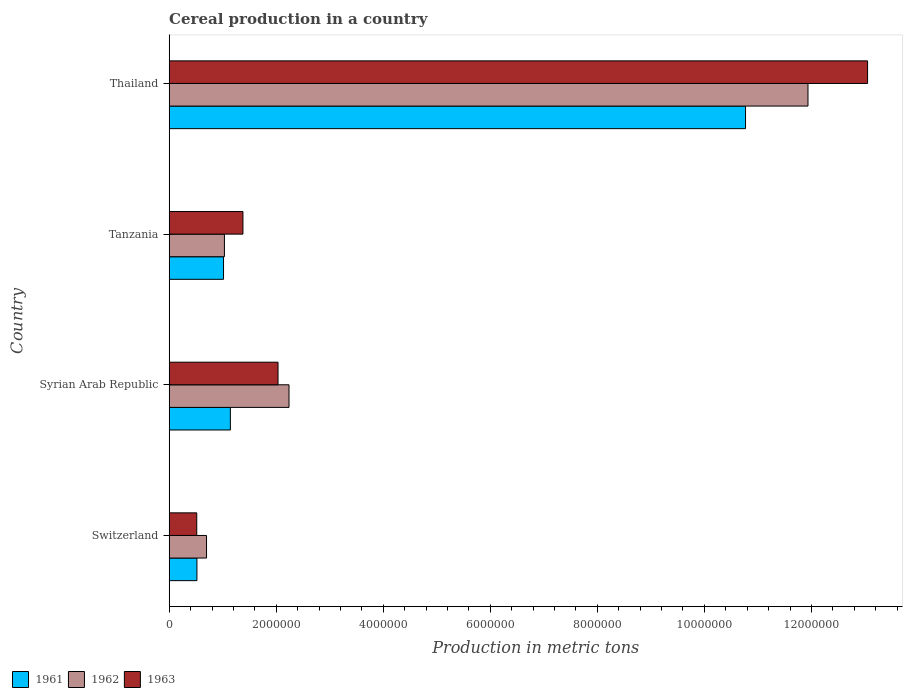How many different coloured bars are there?
Provide a succinct answer. 3. How many groups of bars are there?
Your response must be concise. 4. Are the number of bars per tick equal to the number of legend labels?
Offer a terse response. Yes. Are the number of bars on each tick of the Y-axis equal?
Offer a terse response. Yes. How many bars are there on the 2nd tick from the bottom?
Your answer should be very brief. 3. What is the label of the 4th group of bars from the top?
Your response must be concise. Switzerland. What is the total cereal production in 1961 in Syrian Arab Republic?
Your response must be concise. 1.14e+06. Across all countries, what is the maximum total cereal production in 1962?
Offer a very short reply. 1.19e+07. Across all countries, what is the minimum total cereal production in 1961?
Give a very brief answer. 5.18e+05. In which country was the total cereal production in 1962 maximum?
Your answer should be very brief. Thailand. In which country was the total cereal production in 1962 minimum?
Your answer should be compact. Switzerland. What is the total total cereal production in 1963 in the graph?
Offer a terse response. 1.70e+07. What is the difference between the total cereal production in 1962 in Switzerland and that in Thailand?
Offer a terse response. -1.12e+07. What is the difference between the total cereal production in 1961 in Switzerland and the total cereal production in 1963 in Tanzania?
Make the answer very short. -8.60e+05. What is the average total cereal production in 1962 per country?
Your answer should be compact. 3.98e+06. What is the difference between the total cereal production in 1961 and total cereal production in 1963 in Tanzania?
Your answer should be compact. -3.63e+05. What is the ratio of the total cereal production in 1961 in Syrian Arab Republic to that in Tanzania?
Provide a succinct answer. 1.13. Is the total cereal production in 1962 in Tanzania less than that in Thailand?
Keep it short and to the point. Yes. What is the difference between the highest and the second highest total cereal production in 1963?
Offer a terse response. 1.10e+07. What is the difference between the highest and the lowest total cereal production in 1962?
Provide a short and direct response. 1.12e+07. What does the 1st bar from the bottom in Tanzania represents?
Your answer should be very brief. 1961. How many bars are there?
Your answer should be very brief. 12. Are all the bars in the graph horizontal?
Keep it short and to the point. Yes. How many countries are there in the graph?
Your answer should be compact. 4. Does the graph contain grids?
Give a very brief answer. No. Where does the legend appear in the graph?
Provide a succinct answer. Bottom left. How many legend labels are there?
Keep it short and to the point. 3. How are the legend labels stacked?
Offer a very short reply. Horizontal. What is the title of the graph?
Offer a very short reply. Cereal production in a country. What is the label or title of the X-axis?
Offer a terse response. Production in metric tons. What is the label or title of the Y-axis?
Provide a succinct answer. Country. What is the Production in metric tons in 1961 in Switzerland?
Your answer should be compact. 5.18e+05. What is the Production in metric tons of 1962 in Switzerland?
Offer a terse response. 6.97e+05. What is the Production in metric tons of 1963 in Switzerland?
Give a very brief answer. 5.15e+05. What is the Production in metric tons in 1961 in Syrian Arab Republic?
Your answer should be very brief. 1.14e+06. What is the Production in metric tons of 1962 in Syrian Arab Republic?
Make the answer very short. 2.24e+06. What is the Production in metric tons of 1963 in Syrian Arab Republic?
Offer a very short reply. 2.03e+06. What is the Production in metric tons of 1961 in Tanzania?
Your answer should be compact. 1.02e+06. What is the Production in metric tons of 1962 in Tanzania?
Make the answer very short. 1.03e+06. What is the Production in metric tons of 1963 in Tanzania?
Your response must be concise. 1.38e+06. What is the Production in metric tons of 1961 in Thailand?
Offer a terse response. 1.08e+07. What is the Production in metric tons in 1962 in Thailand?
Your answer should be compact. 1.19e+07. What is the Production in metric tons of 1963 in Thailand?
Your answer should be compact. 1.30e+07. Across all countries, what is the maximum Production in metric tons of 1961?
Your response must be concise. 1.08e+07. Across all countries, what is the maximum Production in metric tons in 1962?
Ensure brevity in your answer.  1.19e+07. Across all countries, what is the maximum Production in metric tons in 1963?
Make the answer very short. 1.30e+07. Across all countries, what is the minimum Production in metric tons of 1961?
Make the answer very short. 5.18e+05. Across all countries, what is the minimum Production in metric tons in 1962?
Keep it short and to the point. 6.97e+05. Across all countries, what is the minimum Production in metric tons of 1963?
Provide a short and direct response. 5.15e+05. What is the total Production in metric tons of 1961 in the graph?
Provide a succinct answer. 1.34e+07. What is the total Production in metric tons in 1962 in the graph?
Ensure brevity in your answer.  1.59e+07. What is the total Production in metric tons in 1963 in the graph?
Ensure brevity in your answer.  1.70e+07. What is the difference between the Production in metric tons in 1961 in Switzerland and that in Syrian Arab Republic?
Your answer should be compact. -6.25e+05. What is the difference between the Production in metric tons of 1962 in Switzerland and that in Syrian Arab Republic?
Provide a succinct answer. -1.54e+06. What is the difference between the Production in metric tons in 1963 in Switzerland and that in Syrian Arab Republic?
Ensure brevity in your answer.  -1.52e+06. What is the difference between the Production in metric tons in 1961 in Switzerland and that in Tanzania?
Make the answer very short. -4.97e+05. What is the difference between the Production in metric tons of 1962 in Switzerland and that in Tanzania?
Make the answer very short. -3.34e+05. What is the difference between the Production in metric tons in 1963 in Switzerland and that in Tanzania?
Provide a succinct answer. -8.63e+05. What is the difference between the Production in metric tons of 1961 in Switzerland and that in Thailand?
Provide a short and direct response. -1.03e+07. What is the difference between the Production in metric tons of 1962 in Switzerland and that in Thailand?
Provide a short and direct response. -1.12e+07. What is the difference between the Production in metric tons of 1963 in Switzerland and that in Thailand?
Make the answer very short. -1.25e+07. What is the difference between the Production in metric tons in 1961 in Syrian Arab Republic and that in Tanzania?
Your response must be concise. 1.28e+05. What is the difference between the Production in metric tons of 1962 in Syrian Arab Republic and that in Tanzania?
Give a very brief answer. 1.21e+06. What is the difference between the Production in metric tons in 1963 in Syrian Arab Republic and that in Tanzania?
Provide a succinct answer. 6.56e+05. What is the difference between the Production in metric tons of 1961 in Syrian Arab Republic and that in Thailand?
Ensure brevity in your answer.  -9.63e+06. What is the difference between the Production in metric tons of 1962 in Syrian Arab Republic and that in Thailand?
Your response must be concise. -9.70e+06. What is the difference between the Production in metric tons of 1963 in Syrian Arab Republic and that in Thailand?
Offer a very short reply. -1.10e+07. What is the difference between the Production in metric tons of 1961 in Tanzania and that in Thailand?
Make the answer very short. -9.75e+06. What is the difference between the Production in metric tons in 1962 in Tanzania and that in Thailand?
Provide a succinct answer. -1.09e+07. What is the difference between the Production in metric tons of 1963 in Tanzania and that in Thailand?
Provide a short and direct response. -1.17e+07. What is the difference between the Production in metric tons in 1961 in Switzerland and the Production in metric tons in 1962 in Syrian Arab Republic?
Keep it short and to the point. -1.72e+06. What is the difference between the Production in metric tons in 1961 in Switzerland and the Production in metric tons in 1963 in Syrian Arab Republic?
Make the answer very short. -1.52e+06. What is the difference between the Production in metric tons in 1962 in Switzerland and the Production in metric tons in 1963 in Syrian Arab Republic?
Your answer should be very brief. -1.34e+06. What is the difference between the Production in metric tons in 1961 in Switzerland and the Production in metric tons in 1962 in Tanzania?
Keep it short and to the point. -5.14e+05. What is the difference between the Production in metric tons of 1961 in Switzerland and the Production in metric tons of 1963 in Tanzania?
Offer a very short reply. -8.60e+05. What is the difference between the Production in metric tons of 1962 in Switzerland and the Production in metric tons of 1963 in Tanzania?
Offer a very short reply. -6.80e+05. What is the difference between the Production in metric tons in 1961 in Switzerland and the Production in metric tons in 1962 in Thailand?
Make the answer very short. -1.14e+07. What is the difference between the Production in metric tons in 1961 in Switzerland and the Production in metric tons in 1963 in Thailand?
Keep it short and to the point. -1.25e+07. What is the difference between the Production in metric tons of 1962 in Switzerland and the Production in metric tons of 1963 in Thailand?
Your answer should be very brief. -1.24e+07. What is the difference between the Production in metric tons in 1961 in Syrian Arab Republic and the Production in metric tons in 1962 in Tanzania?
Ensure brevity in your answer.  1.11e+05. What is the difference between the Production in metric tons of 1961 in Syrian Arab Republic and the Production in metric tons of 1963 in Tanzania?
Provide a succinct answer. -2.35e+05. What is the difference between the Production in metric tons of 1962 in Syrian Arab Republic and the Production in metric tons of 1963 in Tanzania?
Make the answer very short. 8.61e+05. What is the difference between the Production in metric tons in 1961 in Syrian Arab Republic and the Production in metric tons in 1962 in Thailand?
Your answer should be very brief. -1.08e+07. What is the difference between the Production in metric tons of 1961 in Syrian Arab Republic and the Production in metric tons of 1963 in Thailand?
Provide a succinct answer. -1.19e+07. What is the difference between the Production in metric tons in 1962 in Syrian Arab Republic and the Production in metric tons in 1963 in Thailand?
Offer a terse response. -1.08e+07. What is the difference between the Production in metric tons of 1961 in Tanzania and the Production in metric tons of 1962 in Thailand?
Provide a short and direct response. -1.09e+07. What is the difference between the Production in metric tons in 1961 in Tanzania and the Production in metric tons in 1963 in Thailand?
Provide a succinct answer. -1.20e+07. What is the difference between the Production in metric tons in 1962 in Tanzania and the Production in metric tons in 1963 in Thailand?
Your response must be concise. -1.20e+07. What is the average Production in metric tons of 1961 per country?
Give a very brief answer. 3.36e+06. What is the average Production in metric tons of 1962 per country?
Your response must be concise. 3.98e+06. What is the average Production in metric tons in 1963 per country?
Ensure brevity in your answer.  4.24e+06. What is the difference between the Production in metric tons of 1961 and Production in metric tons of 1962 in Switzerland?
Ensure brevity in your answer.  -1.80e+05. What is the difference between the Production in metric tons in 1961 and Production in metric tons in 1963 in Switzerland?
Provide a short and direct response. 3100. What is the difference between the Production in metric tons of 1962 and Production in metric tons of 1963 in Switzerland?
Offer a very short reply. 1.83e+05. What is the difference between the Production in metric tons of 1961 and Production in metric tons of 1962 in Syrian Arab Republic?
Keep it short and to the point. -1.10e+06. What is the difference between the Production in metric tons in 1961 and Production in metric tons in 1963 in Syrian Arab Republic?
Your answer should be compact. -8.91e+05. What is the difference between the Production in metric tons of 1962 and Production in metric tons of 1963 in Syrian Arab Republic?
Keep it short and to the point. 2.05e+05. What is the difference between the Production in metric tons in 1961 and Production in metric tons in 1962 in Tanzania?
Keep it short and to the point. -1.65e+04. What is the difference between the Production in metric tons of 1961 and Production in metric tons of 1963 in Tanzania?
Your response must be concise. -3.63e+05. What is the difference between the Production in metric tons in 1962 and Production in metric tons in 1963 in Tanzania?
Make the answer very short. -3.46e+05. What is the difference between the Production in metric tons in 1961 and Production in metric tons in 1962 in Thailand?
Your answer should be compact. -1.17e+06. What is the difference between the Production in metric tons of 1961 and Production in metric tons of 1963 in Thailand?
Keep it short and to the point. -2.28e+06. What is the difference between the Production in metric tons in 1962 and Production in metric tons in 1963 in Thailand?
Provide a succinct answer. -1.11e+06. What is the ratio of the Production in metric tons in 1961 in Switzerland to that in Syrian Arab Republic?
Keep it short and to the point. 0.45. What is the ratio of the Production in metric tons of 1962 in Switzerland to that in Syrian Arab Republic?
Offer a very short reply. 0.31. What is the ratio of the Production in metric tons in 1963 in Switzerland to that in Syrian Arab Republic?
Your answer should be compact. 0.25. What is the ratio of the Production in metric tons in 1961 in Switzerland to that in Tanzania?
Offer a very short reply. 0.51. What is the ratio of the Production in metric tons of 1962 in Switzerland to that in Tanzania?
Provide a short and direct response. 0.68. What is the ratio of the Production in metric tons of 1963 in Switzerland to that in Tanzania?
Your response must be concise. 0.37. What is the ratio of the Production in metric tons of 1961 in Switzerland to that in Thailand?
Provide a short and direct response. 0.05. What is the ratio of the Production in metric tons in 1962 in Switzerland to that in Thailand?
Provide a short and direct response. 0.06. What is the ratio of the Production in metric tons in 1963 in Switzerland to that in Thailand?
Your response must be concise. 0.04. What is the ratio of the Production in metric tons of 1961 in Syrian Arab Republic to that in Tanzania?
Make the answer very short. 1.13. What is the ratio of the Production in metric tons in 1962 in Syrian Arab Republic to that in Tanzania?
Offer a very short reply. 2.17. What is the ratio of the Production in metric tons in 1963 in Syrian Arab Republic to that in Tanzania?
Your response must be concise. 1.48. What is the ratio of the Production in metric tons of 1961 in Syrian Arab Republic to that in Thailand?
Your answer should be very brief. 0.11. What is the ratio of the Production in metric tons of 1962 in Syrian Arab Republic to that in Thailand?
Keep it short and to the point. 0.19. What is the ratio of the Production in metric tons of 1963 in Syrian Arab Republic to that in Thailand?
Provide a succinct answer. 0.16. What is the ratio of the Production in metric tons in 1961 in Tanzania to that in Thailand?
Offer a terse response. 0.09. What is the ratio of the Production in metric tons in 1962 in Tanzania to that in Thailand?
Provide a succinct answer. 0.09. What is the ratio of the Production in metric tons in 1963 in Tanzania to that in Thailand?
Give a very brief answer. 0.11. What is the difference between the highest and the second highest Production in metric tons in 1961?
Provide a succinct answer. 9.63e+06. What is the difference between the highest and the second highest Production in metric tons of 1962?
Your answer should be very brief. 9.70e+06. What is the difference between the highest and the second highest Production in metric tons of 1963?
Your answer should be very brief. 1.10e+07. What is the difference between the highest and the lowest Production in metric tons in 1961?
Your answer should be very brief. 1.03e+07. What is the difference between the highest and the lowest Production in metric tons in 1962?
Provide a short and direct response. 1.12e+07. What is the difference between the highest and the lowest Production in metric tons in 1963?
Provide a short and direct response. 1.25e+07. 